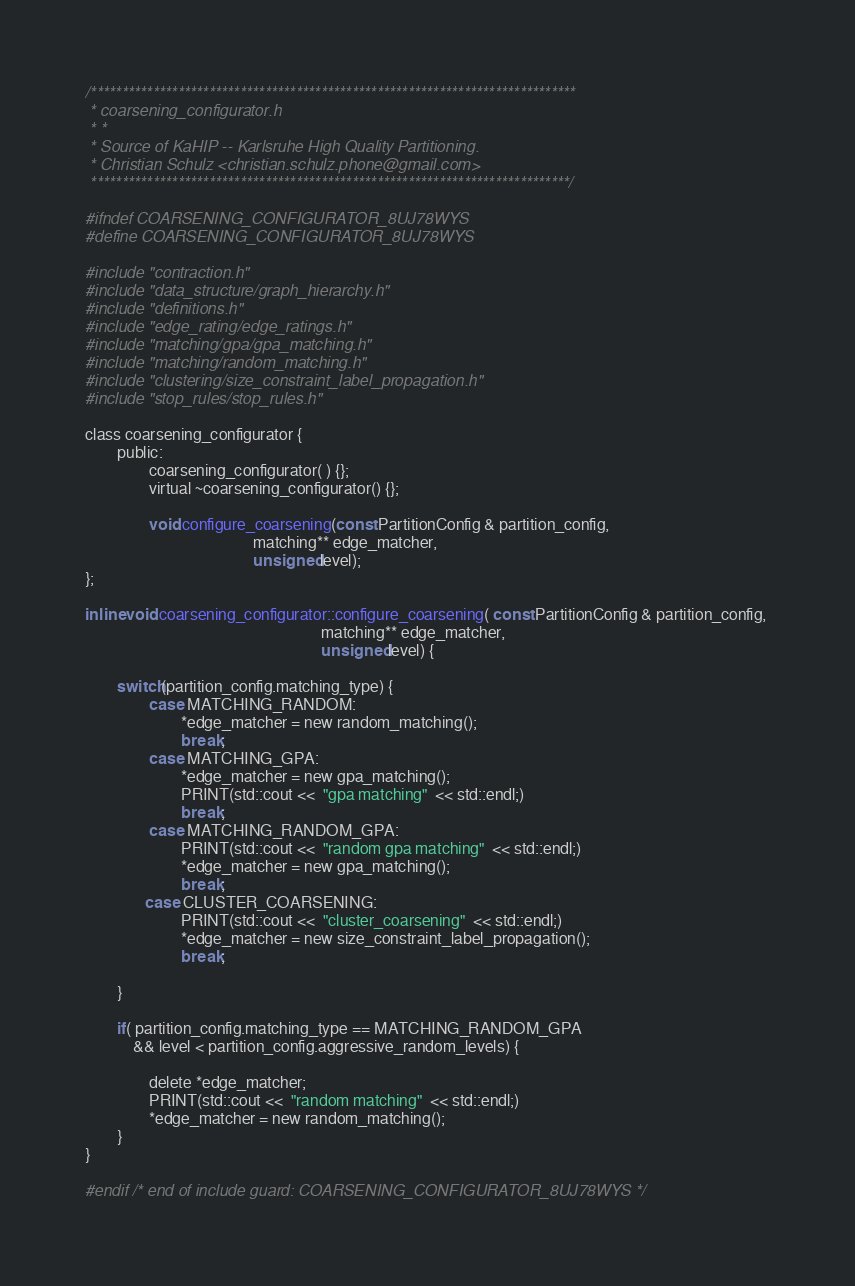<code> <loc_0><loc_0><loc_500><loc_500><_C_>/******************************************************************************
 * coarsening_configurator.h
 * *
 * Source of KaHIP -- Karlsruhe High Quality Partitioning.
 * Christian Schulz <christian.schulz.phone@gmail.com>
 *****************************************************************************/

#ifndef COARSENING_CONFIGURATOR_8UJ78WYS
#define COARSENING_CONFIGURATOR_8UJ78WYS

#include "contraction.h"
#include "data_structure/graph_hierarchy.h"
#include "definitions.h"
#include "edge_rating/edge_ratings.h"
#include "matching/gpa/gpa_matching.h"
#include "matching/random_matching.h"
#include "clustering/size_constraint_label_propagation.h"
#include "stop_rules/stop_rules.h"

class coarsening_configurator {
        public:
                coarsening_configurator( ) {};
                virtual ~coarsening_configurator() {};

                void configure_coarsening(const PartitionConfig & partition_config, 
                                          matching** edge_matcher, 
                                          unsigned level); 
};

inline void coarsening_configurator::configure_coarsening( const PartitionConfig & partition_config, 
                                                           matching** edge_matcher, 
                                                           unsigned level) {

        switch(partition_config.matching_type) {
                case MATCHING_RANDOM: 
                        *edge_matcher = new random_matching();
                        break; 
                case MATCHING_GPA:
                        *edge_matcher = new gpa_matching();
                        PRINT(std::cout <<  "gpa matching"  << std::endl;)
                        break;
                case MATCHING_RANDOM_GPA:
                        PRINT(std::cout <<  "random gpa matching"  << std::endl;)
                        *edge_matcher = new gpa_matching();
                        break;
               case CLUSTER_COARSENING:
                        PRINT(std::cout <<  "cluster_coarsening"  << std::endl;)
                        *edge_matcher = new size_constraint_label_propagation();
                        break;

        }

        if( partition_config.matching_type == MATCHING_RANDOM_GPA 
            && level < partition_config.aggressive_random_levels) {

                delete *edge_matcher;
                PRINT(std::cout <<  "random matching"  << std::endl;)
                *edge_matcher = new random_matching();
        }  
}

#endif /* end of include guard: COARSENING_CONFIGURATOR_8UJ78WYS */
</code> 